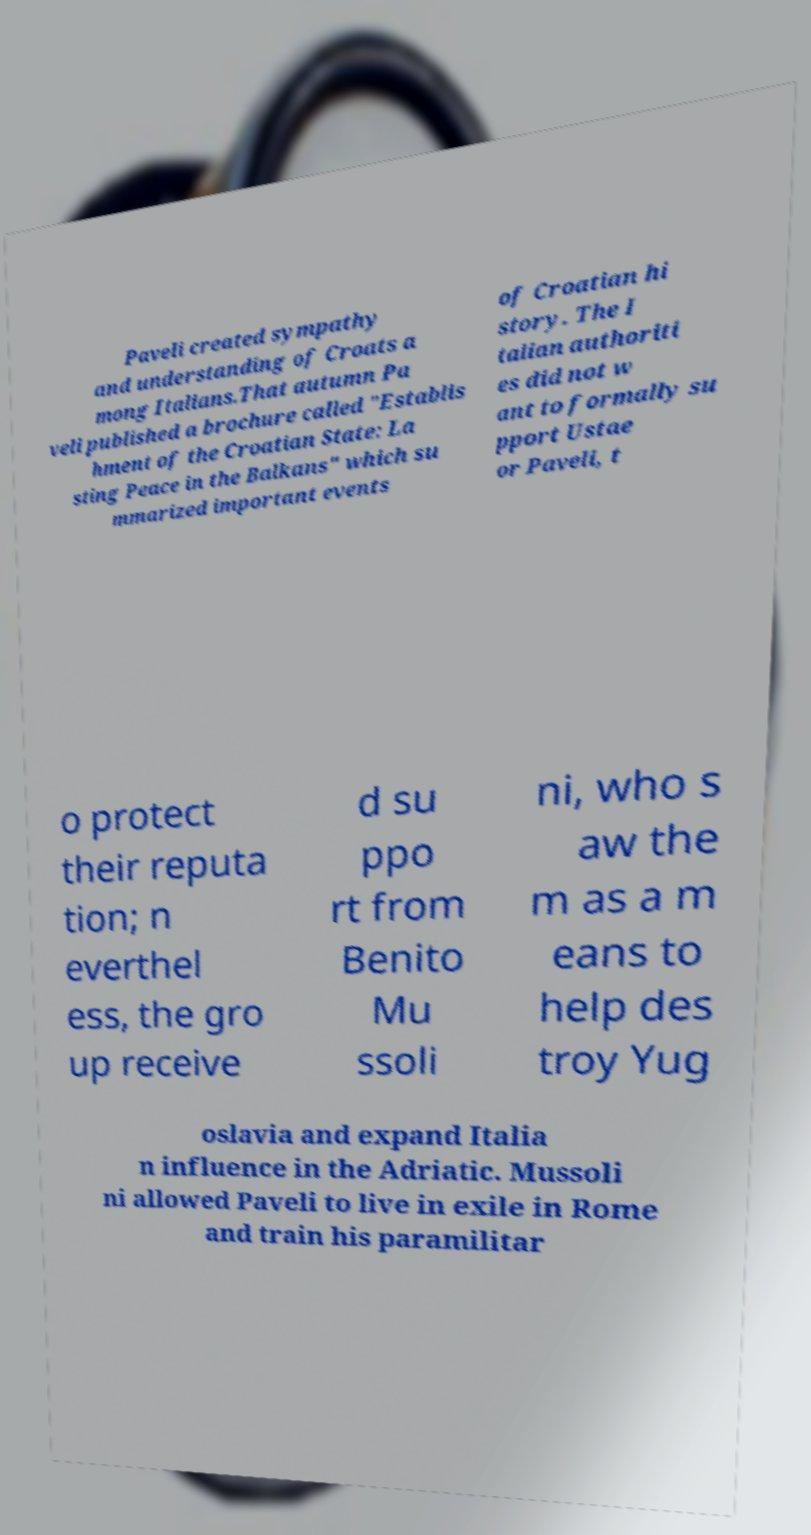Could you extract and type out the text from this image? Paveli created sympathy and understanding of Croats a mong Italians.That autumn Pa veli published a brochure called "Establis hment of the Croatian State: La sting Peace in the Balkans" which su mmarized important events of Croatian hi story. The I talian authoriti es did not w ant to formally su pport Ustae or Paveli, t o protect their reputa tion; n everthel ess, the gro up receive d su ppo rt from Benito Mu ssoli ni, who s aw the m as a m eans to help des troy Yug oslavia and expand Italia n influence in the Adriatic. Mussoli ni allowed Paveli to live in exile in Rome and train his paramilitar 